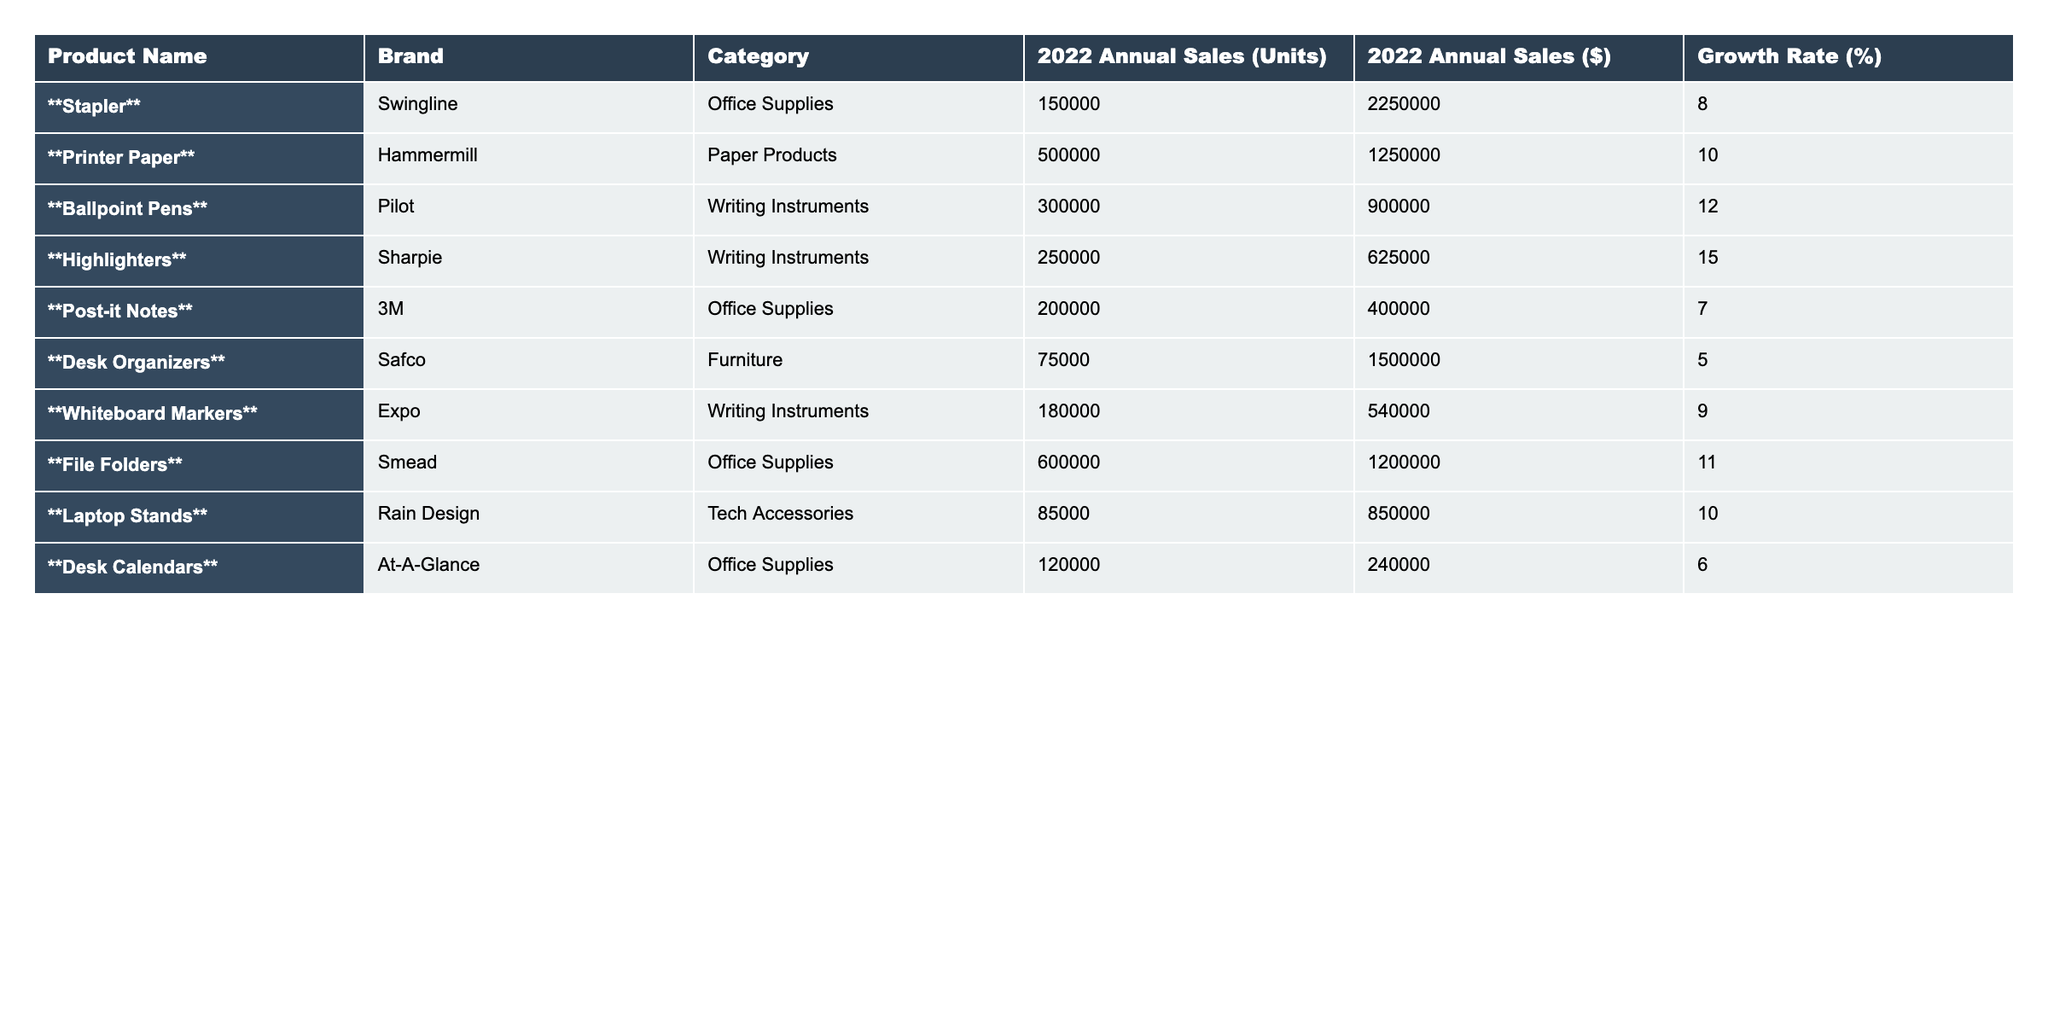What product had the highest annual sales in units? By examining the 2022 Annual Sales (Units) column, we see that File Folders had the highest figure at 600,000 units sold.
Answer: File Folders What is the total annual sales revenue for all products combined? To find the total revenue, we sum the values in the 2022 Annual Sales ($) column: 2,250,000 + 1,250,000 + 900,000 + 625,000 + 400,000 + 1,500,000 + 540,000 + 1,200,000 + 850,000 + 240,000 = 9,855,000.
Answer: 9,855,000 Did Desk Organizers have a growth rate greater than 5%? Looking at the Growth Rate (%) column, Desk Organizers have a growth rate of 5%, which means it is not greater than 5%.
Answer: No Which product category had the highest average sales in dollars? First, we calculate the total revenue for each category: Office Supplies $4,850,000, Paper Products $1,250,000, Writing Instruments $2,055,000, Furniture $1,500,000, and Tech Accessories $850,000. Then, we find the average for each category based on the number of products: Office Supplies has 5 products ($4,850,000 / 5 = $970,000), Paper Products has 1 product ($1,250,000), Writing Instruments has 3 products ($2,055,000 / 3 ≈ $685,000), Furniture has 1 product ($1,500,000), and Tech Accessories has 1 product ($850,000). The highest average is from Office Supplies.
Answer: Office Supplies How many writing instruments were sold in total? To find the total for Writing Instruments, we add the units sold: 300,000 (Ballpoint Pens) + 250,000 (Highlighters) + 180,000 (Whiteboard Markers) = 730,000.
Answer: 730,000 Is the growth rate of Post-it Notes higher than that of Highlighters? Post-it Notes has a growth rate of 7%, while Highlighters have a growth rate of 15%. Since 7% is less than 15%, the statement is false.
Answer: No What was the growth rate difference between Laptop Stands and Printer Paper? Laptop Stands have a growth rate of 10%, while Printer Paper has a growth rate of 10%. The difference is 10% - 10% = 0%.
Answer: 0% Which product had the lowest growth rate? By checking the Growth Rate (%) column, we find that Desk Organizers had the lowest growth rate at 5%.
Answer: Desk Organizers 